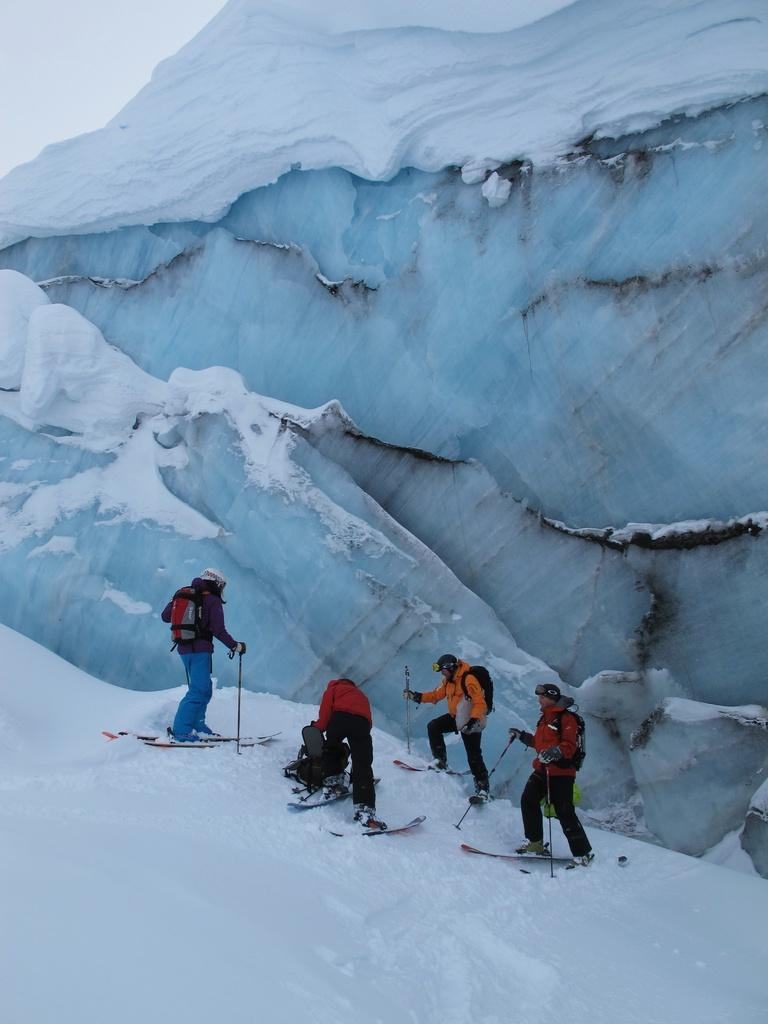How many people are in the image? There are four people in the image. What are the people doing in the image? The people are standing and riding on snow skiing. What are the people wearing in the image? The people are wearing clothes. What is the color of the background in the image? The background of the image has a snow white color. Can you see any pizzas being delivered in the image? There are no pizzas or pizza delivery in the image; it features people skiing on a snowy background. 